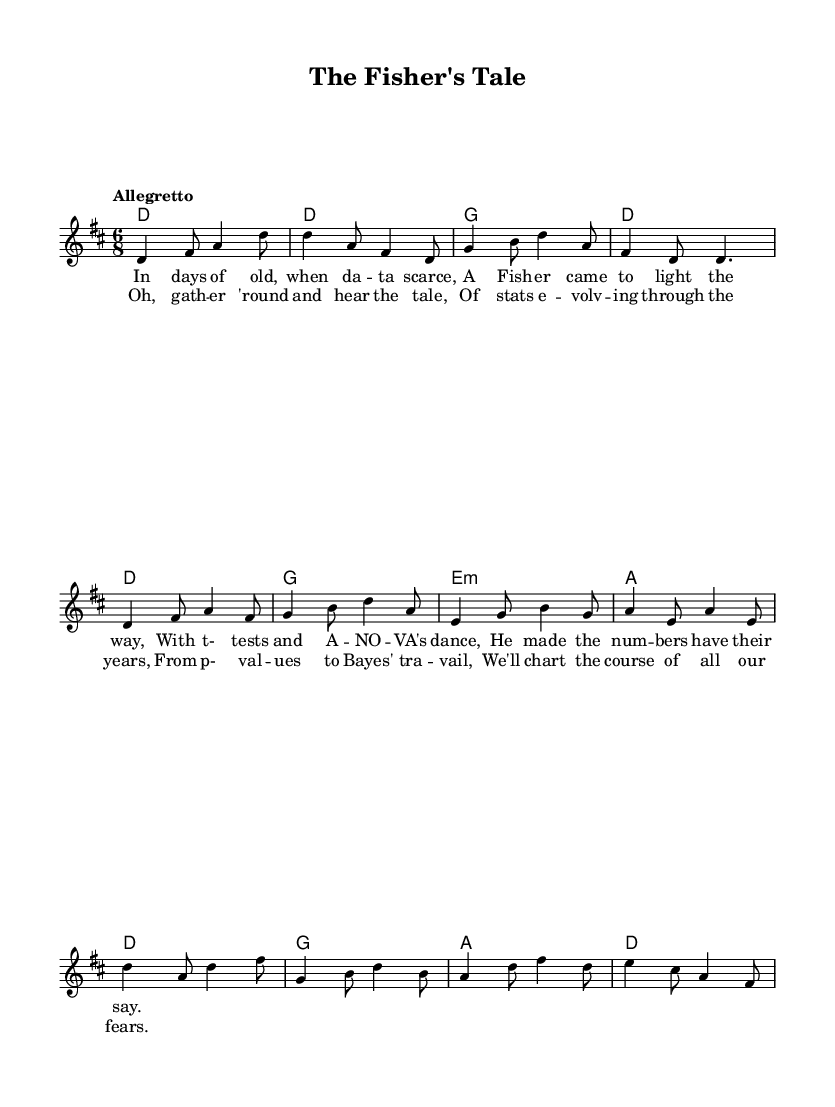What is the key signature of this music? The key signature indicated in the global section is D major, which features two sharps (F# and C#).
Answer: D major What is the time signature of this music? The time signature presented in the global section of the code is 6/8, indicating there are six eighth notes per measure.
Answer: 6/8 What is the tempo marking of this piece? The tempo marking given is "Allegretto," which suggests a moderately fast pace, generally around 98 to 109 beats per minute.
Answer: Allegretto How many bars are in the verse section? By analyzing the melody provided, there are four distinct lines of music for the verse, each containing two bars, leading to a total of eight bars.
Answer: Eight What is the pattern of the chorus lyrics in terms of syllables? The chorus consists of two lines, with each line having a rhythm that follows a pattern of 8 + 8 syllables, enhancing its folk style.
Answer: 8 + 8 syllables Which statistical methods are mentioned in the first verse? The first verse mentions t-tests and ANOVA, which are both fundamental statistical techniques used in hypothesis testing and analysis of variance respectively.
Answer: t-tests and ANOVA How does the musical structure reflect the folk genre? The structure includes verses and a repetitive chorus, which is characteristic of folk music, allowing for storytelling and audience participation.
Answer: Verses and chorus 